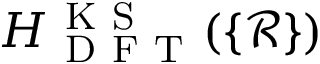<formula> <loc_0><loc_0><loc_500><loc_500>H _ { D F T } ^ { K S } ( \{ \mathcal { R } \} )</formula> 